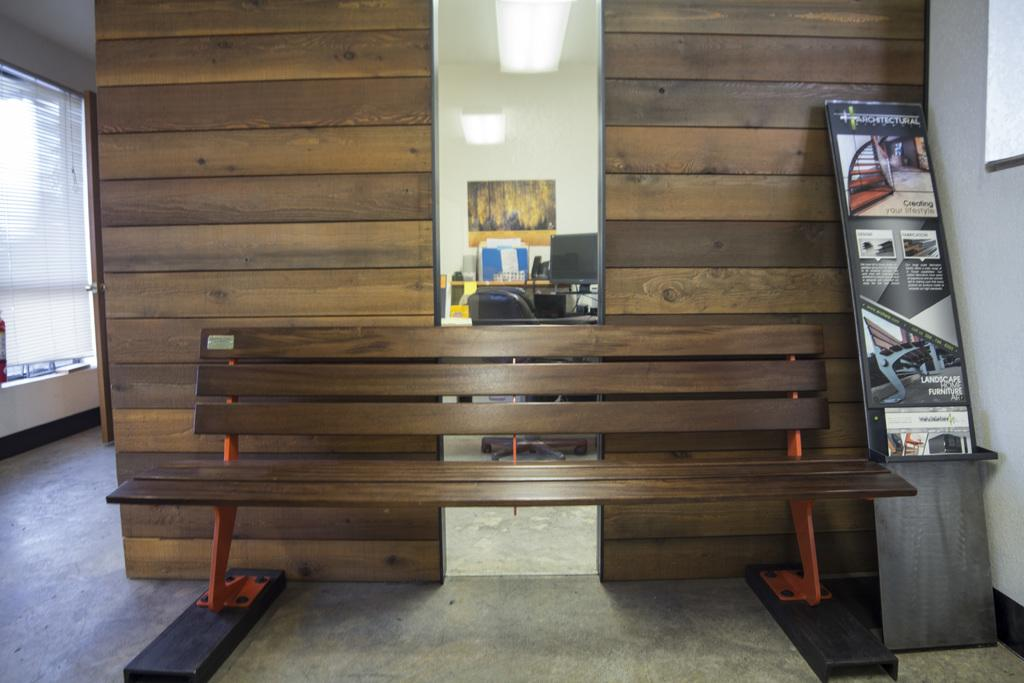What is placed on the floor in the image? There is a bench on the floor in the image. What can be seen on the walls in the image? There are posters and lights in the image. What type of furniture is present in the image? There is a bench, a chair, and a monitor in the image. What is visible in the background of the image? There is a door and a curtain in the background of the image. Can you describe the objects in the image? There are some objects in the image, but their specific nature is not mentioned in the facts. What type of cake is being served on the sidewalk in the image? There is no cake or sidewalk present in the image; it features a bench, posters, lights, walls, a monitor, a chair, and background objects. 